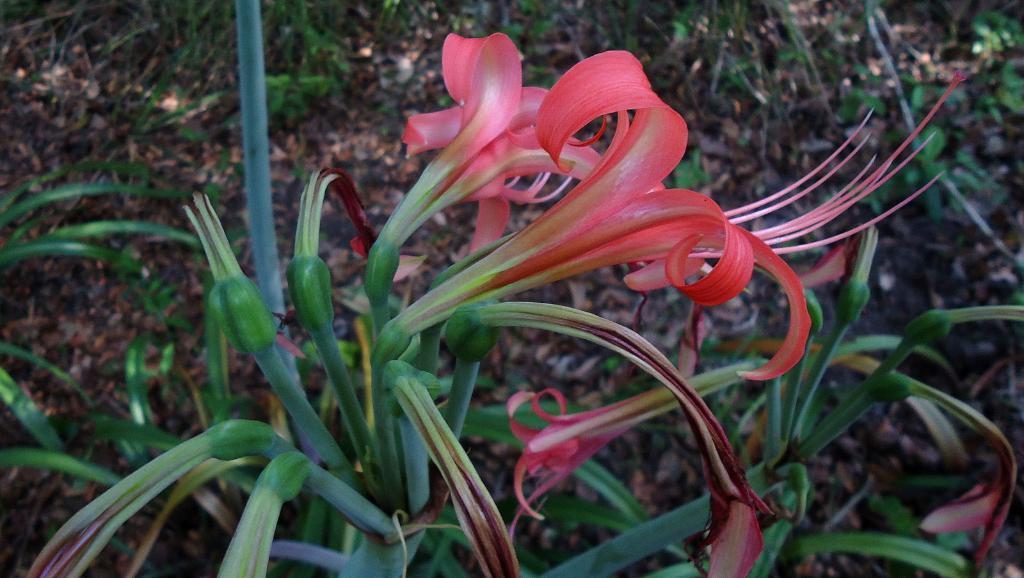Please provide a concise description of this image. In this picture we can see plants with flowers and buds. Behind the plants, there are dried leaves and grass. 